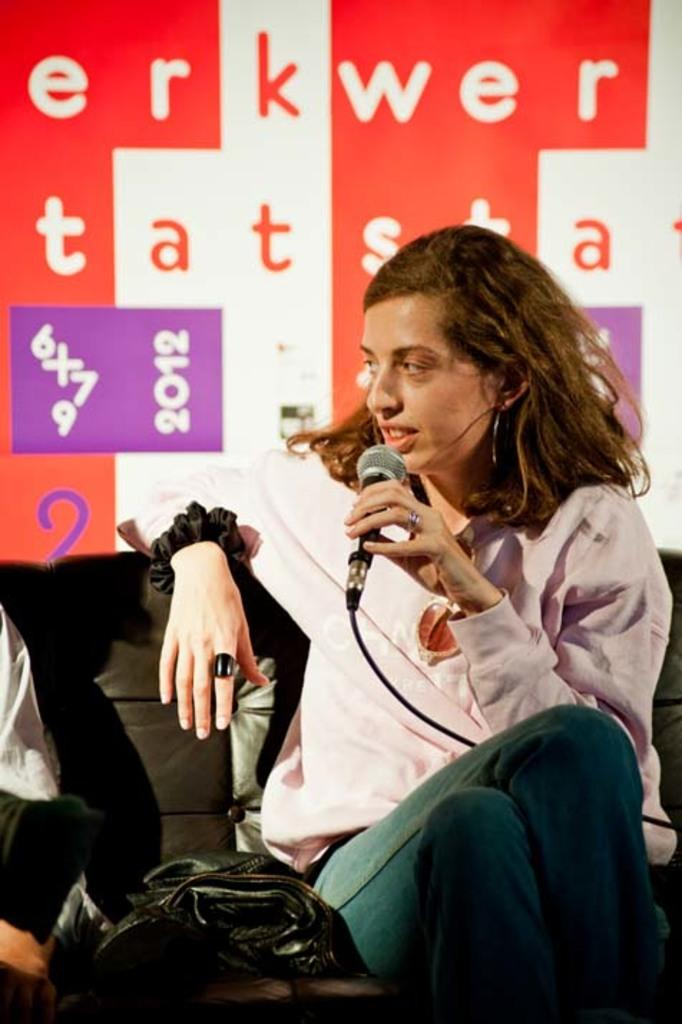How many people are in the image? There are people in the image, but the exact number is not specified. What is one person doing in the image? One person is sitting on a chair in the image. What object is the person holding? The person is holding a microphone. What can be seen on the board in the image? There is a board with text in the image. What type of jewel is the person wearing on their head in the image? There is no mention of a jewel or any headwear in the image, so it cannot be determined from the facts provided. 